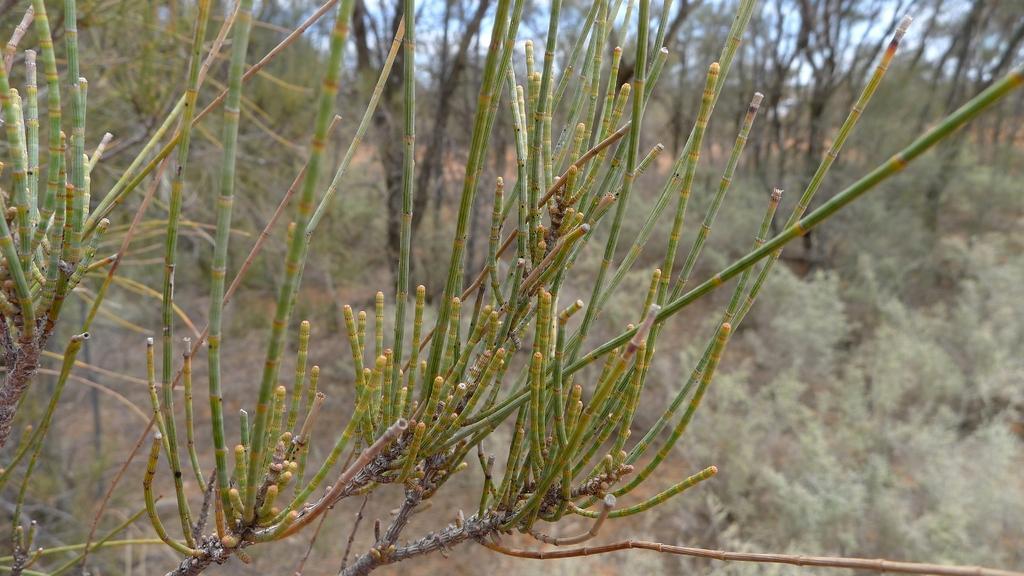Describe this image in one or two sentences. In this image we can see branches of trees. In the background there are trees. 